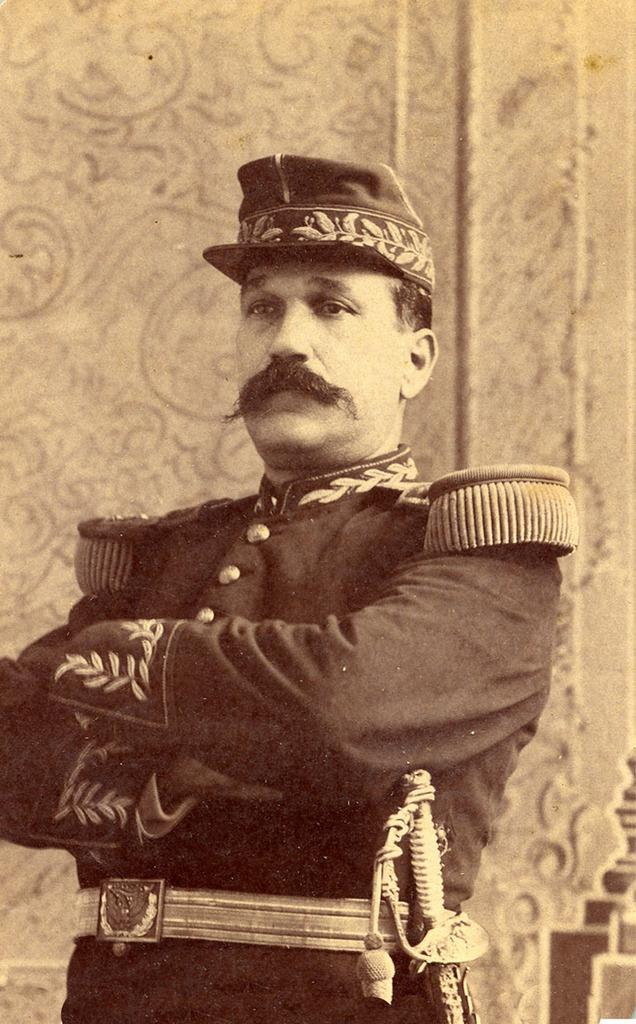What is the main subject of the image? There is a person in the image. What is the person wearing? The person is wearing a uniform and a cap. What is the person holding? The person is holding a sword. What can be seen in the background of the image? There is a wall in the background of the image. What type of sticks are being used for a business meeting in the image? There are no sticks or business meetings present in the image. Is there a camp visible in the background of the image? There is no camp visible in the image; only a wall is present in the background. 